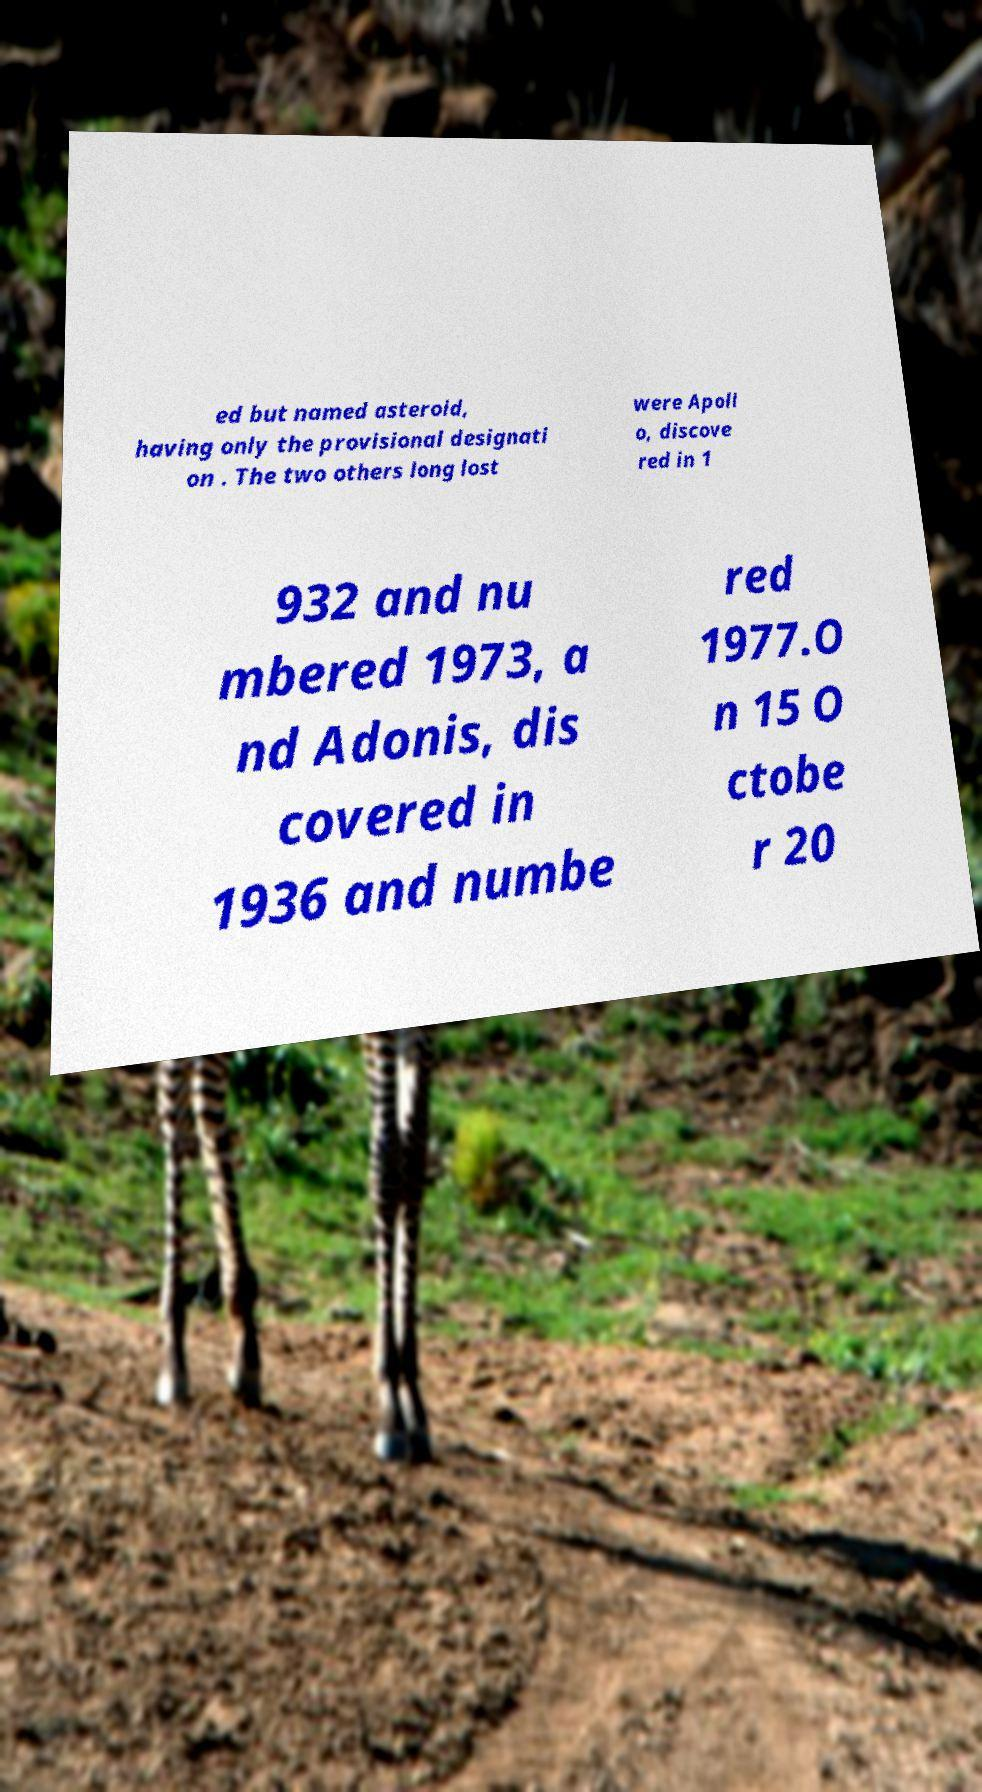There's text embedded in this image that I need extracted. Can you transcribe it verbatim? ed but named asteroid, having only the provisional designati on . The two others long lost were Apoll o, discove red in 1 932 and nu mbered 1973, a nd Adonis, dis covered in 1936 and numbe red 1977.O n 15 O ctobe r 20 